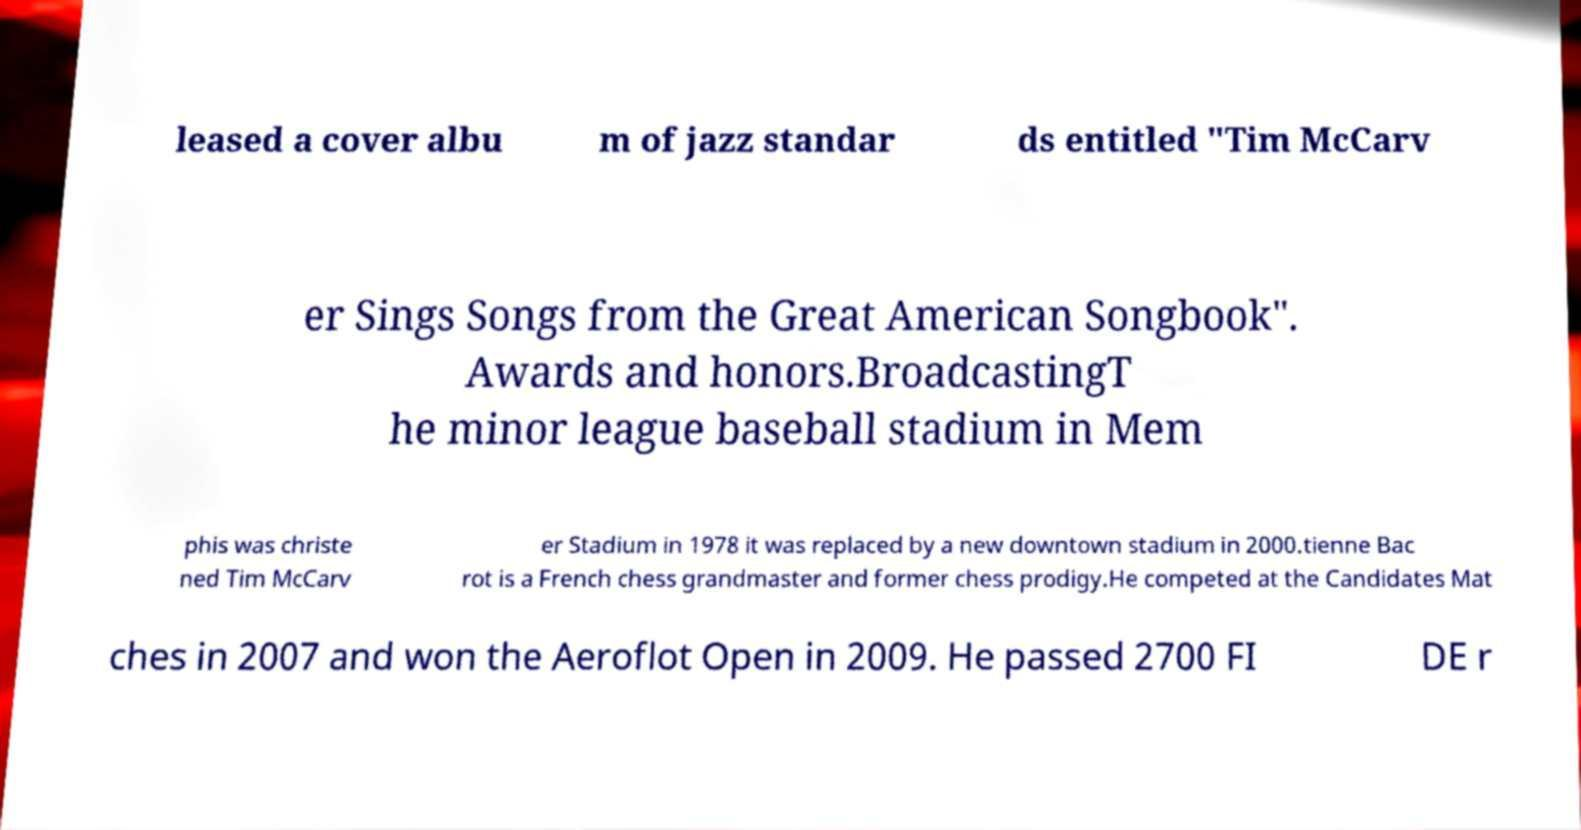Can you read and provide the text displayed in the image?This photo seems to have some interesting text. Can you extract and type it out for me? leased a cover albu m of jazz standar ds entitled "Tim McCarv er Sings Songs from the Great American Songbook". Awards and honors.BroadcastingT he minor league baseball stadium in Mem phis was christe ned Tim McCarv er Stadium in 1978 it was replaced by a new downtown stadium in 2000.tienne Bac rot is a French chess grandmaster and former chess prodigy.He competed at the Candidates Mat ches in 2007 and won the Aeroflot Open in 2009. He passed 2700 FI DE r 